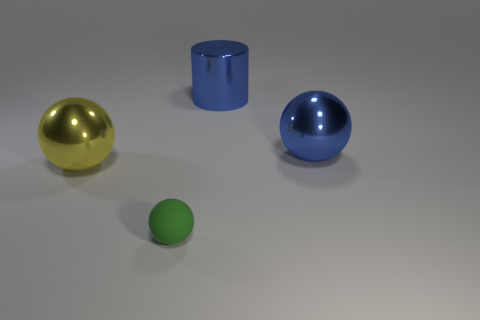Add 4 large red cylinders. How many objects exist? 8 Subtract all cylinders. How many objects are left? 3 Subtract all large metallic things. Subtract all large blue metallic spheres. How many objects are left? 0 Add 2 big yellow metallic objects. How many big yellow metallic objects are left? 3 Add 2 big blue cylinders. How many big blue cylinders exist? 3 Subtract 0 gray cylinders. How many objects are left? 4 